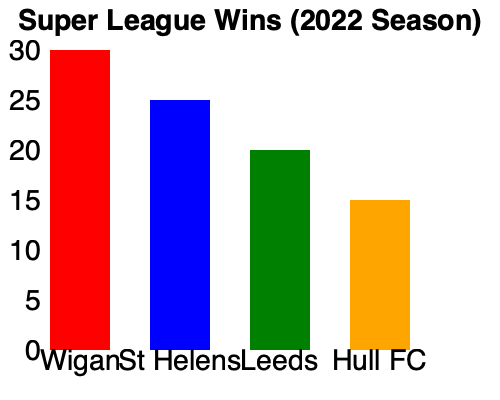Based on the bar graph showing the number of wins for four Super League teams in the 2022 season, what is the difference in wins between the top-performing team and the bottom-performing team? To find the difference in wins between the top-performing and bottom-performing teams, we need to:

1. Identify the top-performing team:
   Wigan has the tallest bar, reaching the 30-win mark.

2. Identify the bottom-performing team:
   Hull FC has the shortest bar, reaching the 15-win mark.

3. Calculate the difference:
   Wigan's wins: 30
   Hull FC's wins: 15
   
   Difference = Top team's wins - Bottom team's wins
               = 30 - 15
               = 15

Therefore, the difference in wins between the top-performing team (Wigan) and the bottom-performing team (Hull FC) is 15 games.
Answer: 15 wins 